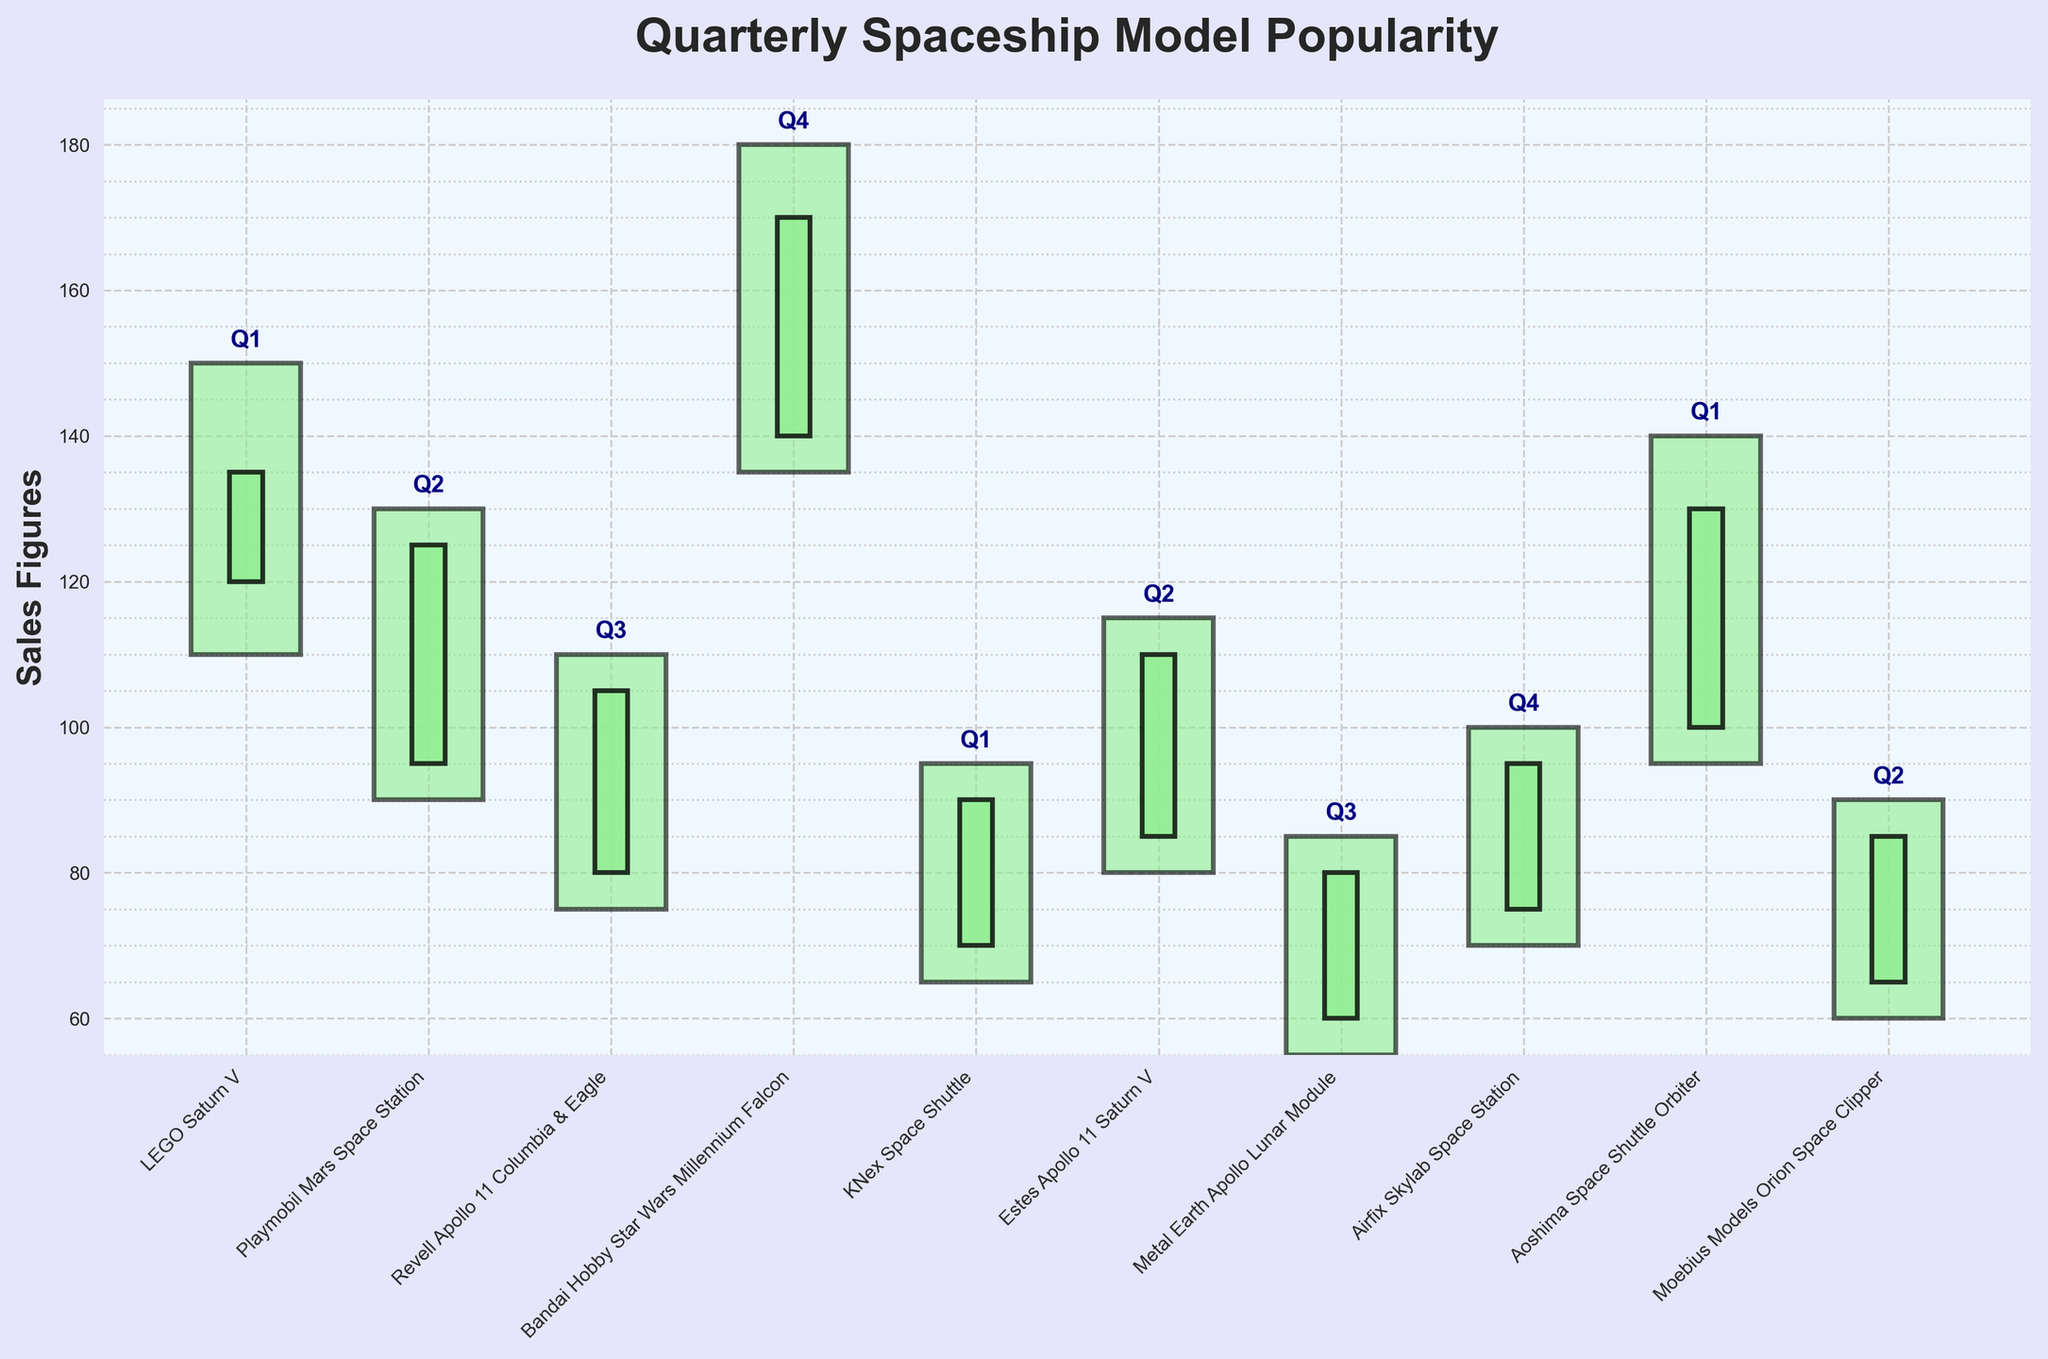What's the title of the figure? The title of the figure is written at the top center of the chart, it reads "Quarterly Spaceship Model Popularity".
Answer: Quarterly Spaceship Model Popularity How many spaceship models are displayed in the chart? There are 10 distinct models indicated by the labeled bars along the x-axis of the chart, each representing a spaceship model.
Answer: 10 Which spaceship model had the highest sales figure in any quarter? The highest sales figure is represented by the tallest bar reaching 180 on the y-axis, and it corresponds to "Bandai Hobby Star Wars Millennium Falcon" in Q4.
Answer: Bandai Hobby Star Wars Millennium Falcon What was the lowest closing sales figure and for which spaceship model? The lowest closing sales figure can be found at the bottommost part of the close segments of the bars. The figure lies at 80 for "Metal Earth Apollo Lunar Module" in Q3.
Answer: 80, Metal Earth Apollo Lunar Module Which spaceship model shows a decrease in sales from opening to closing in its respective quarter? A decrease from opening to closing is shown by red bars. Upon examining the bars, "Playmobil Mars Space Station" in Q2 showed a decrease in sales from 95 to 90.
Answer: Playmobil Mars Space Station What is the average high sales figure for Q1 models? To find the average high for Q1 models: (150 for LEGO Saturn V + 95 for KNex Space Shuttle + 140 for Aoshima Space Shuttle Orbiter) / 3 = (150+95+140)/3 = 385/3
Answer: 128.33 (approximately) Compare the closing sales figures of Q2 vs Q3 for the Estes Apollo 11 Saturn V model. Which quarter had higher sales? In Q2, the closing sales figure for Estes Apollo 11 Saturn V is 110. In Q3, the closing figure can be checked as there does not exist a matching model entry, Hence for Q2.
Answer: Q2 had higher sales What is the difference between the highest and lowest sales figure for "Revell Apollo 11 Columbia & Eagle"? The difference is calculated by subtracting the lowest sales figure (75) from the highest (110) for the "Revell Apollo 11 Columbia & Eagle". Difference = 110 - 75 = 35
Answer: 35 Which quarter shows the most number of models? By counting the quarters labeled next to each model: Q1 has LEGO Saturn V, KNex Space Shuttle, Aoshima Space Shuttle Orbiter indicating Q1 has the most number of models.
Answer: Q1 Across all quarters, which model had the smallest range between its highest and lowest sales figures and what is the range? By observing the highest and lowest figures for each model, "Moebius Models Orion Space Clipper" in Q2 has the smallest range: 90-60 = 30.
Answer: Moebius Models Orion Space Clipper, 30 